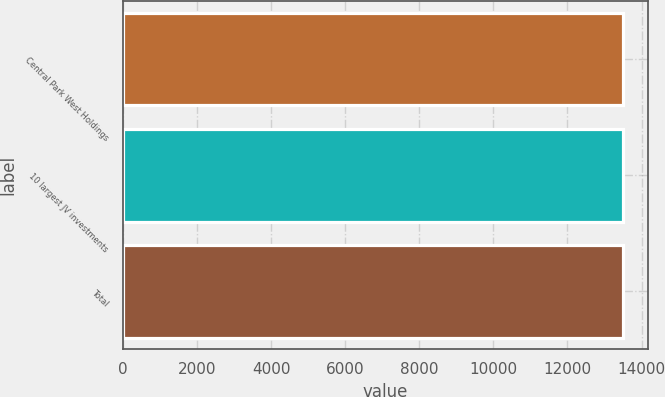Convert chart to OTSL. <chart><loc_0><loc_0><loc_500><loc_500><bar_chart><fcel>Central Park West Holdings<fcel>10 largest JV investments<fcel>Total<nl><fcel>13500<fcel>13500.1<fcel>13500.2<nl></chart> 